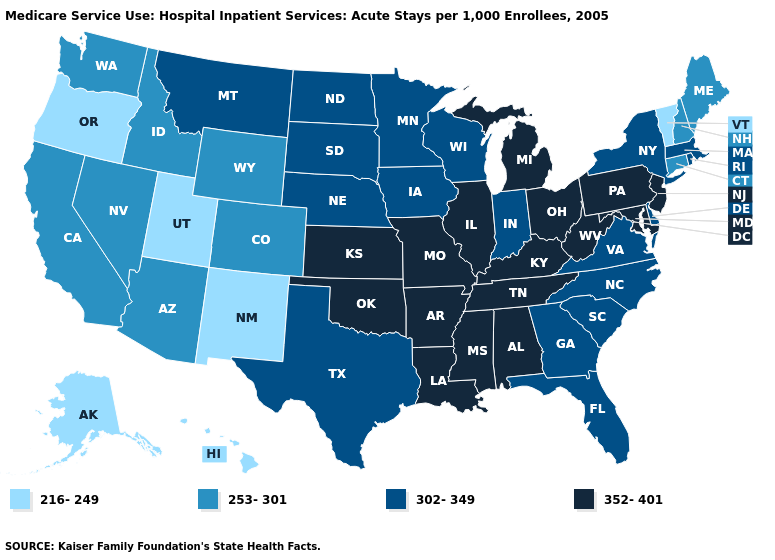What is the value of West Virginia?
Write a very short answer. 352-401. What is the highest value in the USA?
Short answer required. 352-401. Name the states that have a value in the range 352-401?
Answer briefly. Alabama, Arkansas, Illinois, Kansas, Kentucky, Louisiana, Maryland, Michigan, Mississippi, Missouri, New Jersey, Ohio, Oklahoma, Pennsylvania, Tennessee, West Virginia. Name the states that have a value in the range 253-301?
Be succinct. Arizona, California, Colorado, Connecticut, Idaho, Maine, Nevada, New Hampshire, Washington, Wyoming. What is the value of Pennsylvania?
Answer briefly. 352-401. Which states hav the highest value in the Northeast?
Keep it brief. New Jersey, Pennsylvania. What is the highest value in the West ?
Be succinct. 302-349. Among the states that border Ohio , does Michigan have the highest value?
Keep it brief. Yes. Name the states that have a value in the range 352-401?
Quick response, please. Alabama, Arkansas, Illinois, Kansas, Kentucky, Louisiana, Maryland, Michigan, Mississippi, Missouri, New Jersey, Ohio, Oklahoma, Pennsylvania, Tennessee, West Virginia. What is the highest value in states that border Louisiana?
Answer briefly. 352-401. Does Rhode Island have a higher value than Michigan?
Give a very brief answer. No. What is the lowest value in states that border North Dakota?
Short answer required. 302-349. What is the value of Minnesota?
Concise answer only. 302-349. What is the value of Florida?
Concise answer only. 302-349. What is the value of Kentucky?
Answer briefly. 352-401. 